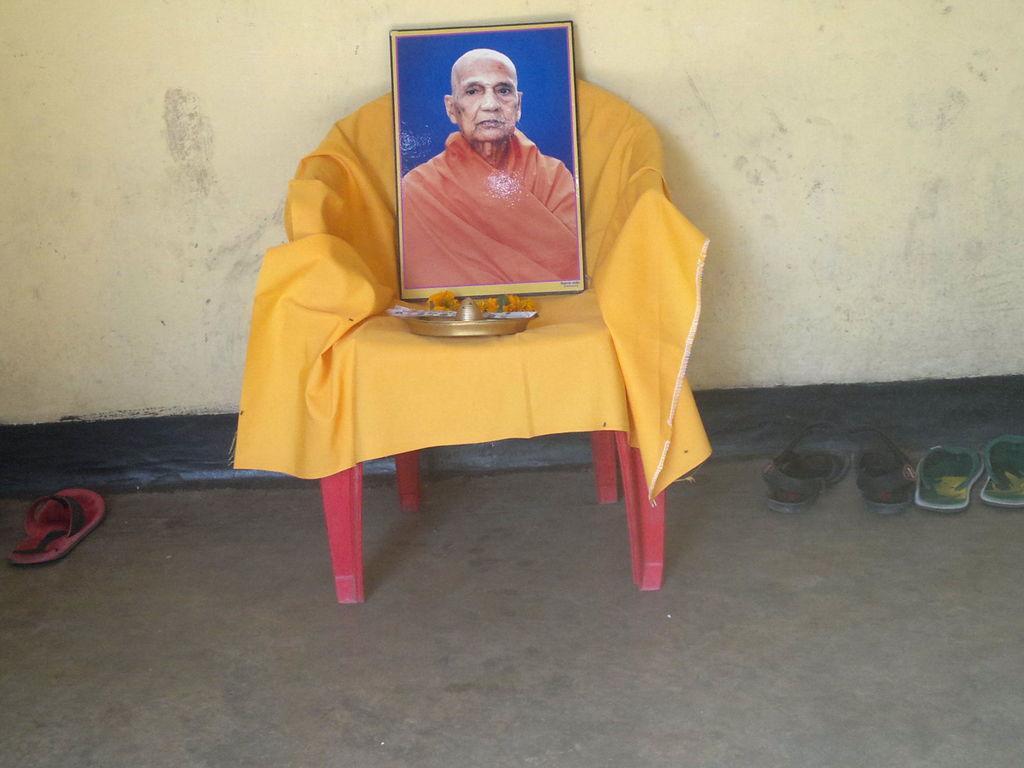Please provide a concise description of this image. This picture might be taken inside a room. In this image, in the middle, we can see a chair, on that chair, we can see a cloth, plate, flowers and a photo frame. On the right side, we can also see two pairs of chappal. On the left side, we can also see a chappal. In the background, we can also see a wall. 